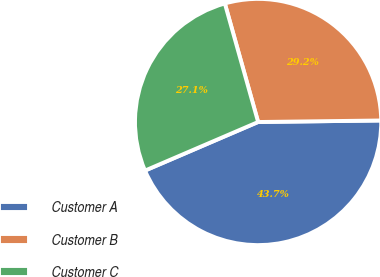Convert chart. <chart><loc_0><loc_0><loc_500><loc_500><pie_chart><fcel>Customer A<fcel>Customer B<fcel>Customer C<nl><fcel>43.74%<fcel>29.16%<fcel>27.1%<nl></chart> 